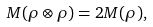Convert formula to latex. <formula><loc_0><loc_0><loc_500><loc_500>M ( \rho \otimes \rho ) = 2 M ( \rho ) ,</formula> 